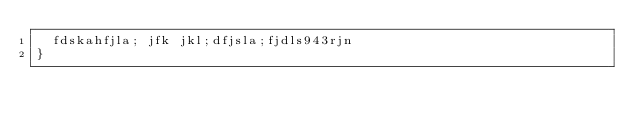<code> <loc_0><loc_0><loc_500><loc_500><_CSS_>  fdskahfjla; jfk jkl;dfjsla;fjdls943rjn
}
</code> 